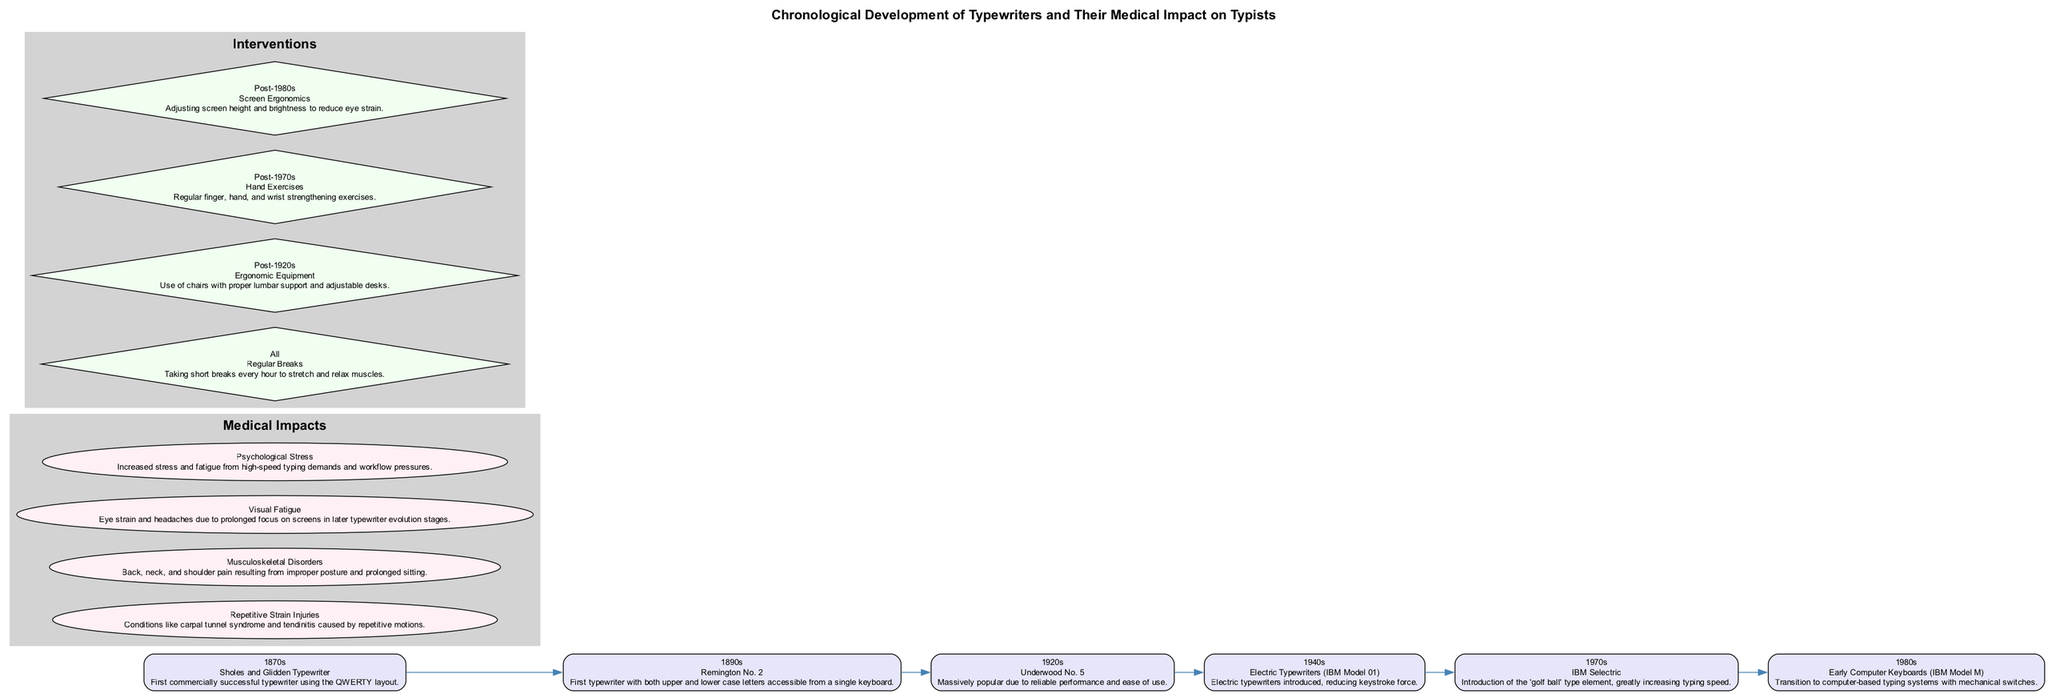What typewriter model was introduced in the 1920s? The diagram lists the Underwood No. 5 as the typewriter model for the 1920s period. It is specifically mentioned in the timeline section dedicated to that era.
Answer: Underwood No. 5 What medical impact was associated with the Remington No. 2? According to the impact analysis section of the diagram, the Remington No. 2 is associated with the introduction of repetitive strain injuries due to widespread typing.
Answer: Repetitive strain injuries How many stages are in the timeline? By counting the individual periods in the timeline sections, we see there are six listed stages: 1870s, 1890s, 1920s, 1940s, 1970s, and 1980s.
Answer: Six Which intervention is recommended for all eras? The diagram indicates that taking regular breaks is a universal recommendation listed under the interventions section.
Answer: Regular Breaks What was a significant ergonomic consideration introduced with electric typewriters? The diagram notes that electric typewriters, like the IBM Model 01 introduced in the 1940s, reduced keystroke force, thus improving ergonomic conditions compared to earlier models.
Answer: Reduced keystroke force Which medical impact emerged from the increased use of typewriters in the 1920s? The impact analysis lists increased cases of typist's cramp and musculoskeletal issues as resulting from typing with typewriters during this period, reflecting a crucial change related to that era's typewriter model.
Answer: Typist's cramp and musculoskeletal issues What ergonomic intervention is highlighted post-1980s? The diagram specifies screen ergonomics as an important intervention that focuses on adjusting screen height and brightness to counteract eye strain in typing environments.
Answer: Screen Ergonomics What type of psychological issue might arise from high-speed typing? The diagram mentions that increased stress and fatigue due to rapid typing demands can lead to psychological stress, discussed in the impact analysis section.
Answer: Psychological Stress What type of nodes represent medical impacts in the diagram? The medical impacts are presented as ellipse-shaped nodes in the cluster indicating their status and role within the pathway, connecting their definitions to the relevant typewriting stages.
Answer: Ellipse-shaped nodes 